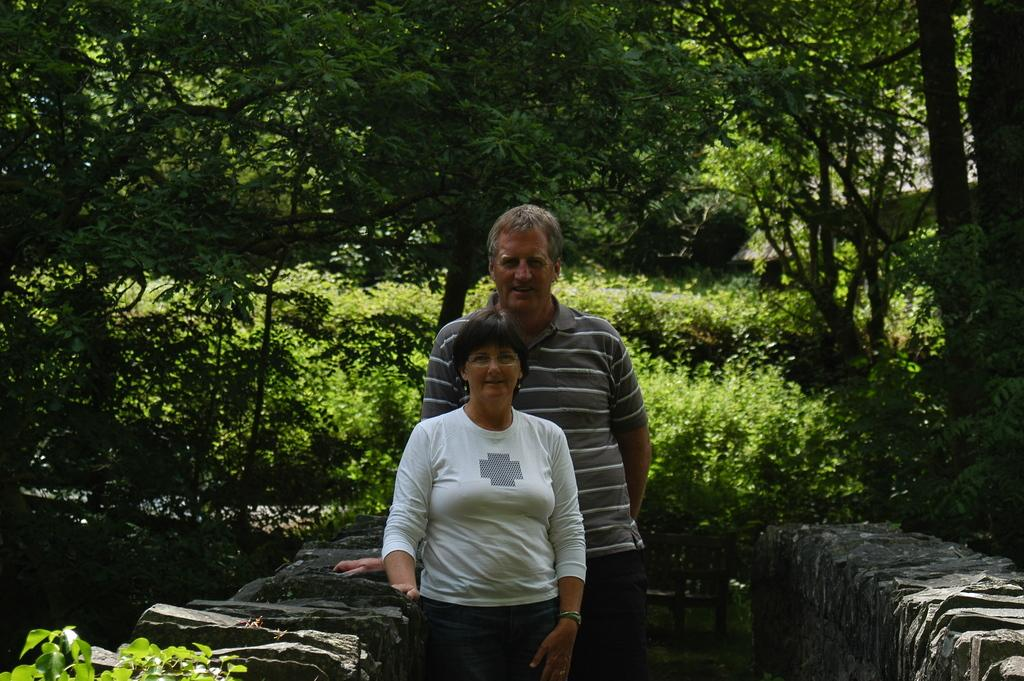How many people are in the image? There are two persons standing in the middle of the image. What are the people doing in the image? The persons are smiling. What can be seen in the background of the image? There is a wall, trees, and plants in the background of the image. What type of star can be seen shining brightly in the image? There is no star visible in the image; it features two persons standing and smiling in front of a background with a wall, trees, and plants. How many ears of corn are visible in the image? There is no corn present in the image. 